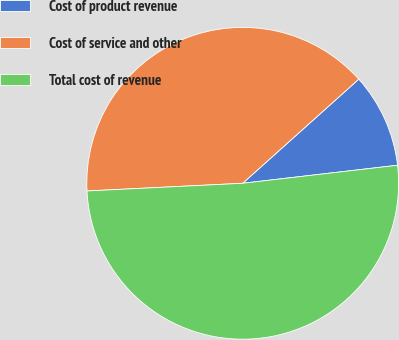<chart> <loc_0><loc_0><loc_500><loc_500><pie_chart><fcel>Cost of product revenue<fcel>Cost of service and other<fcel>Total cost of revenue<nl><fcel>9.79%<fcel>39.15%<fcel>51.06%<nl></chart> 